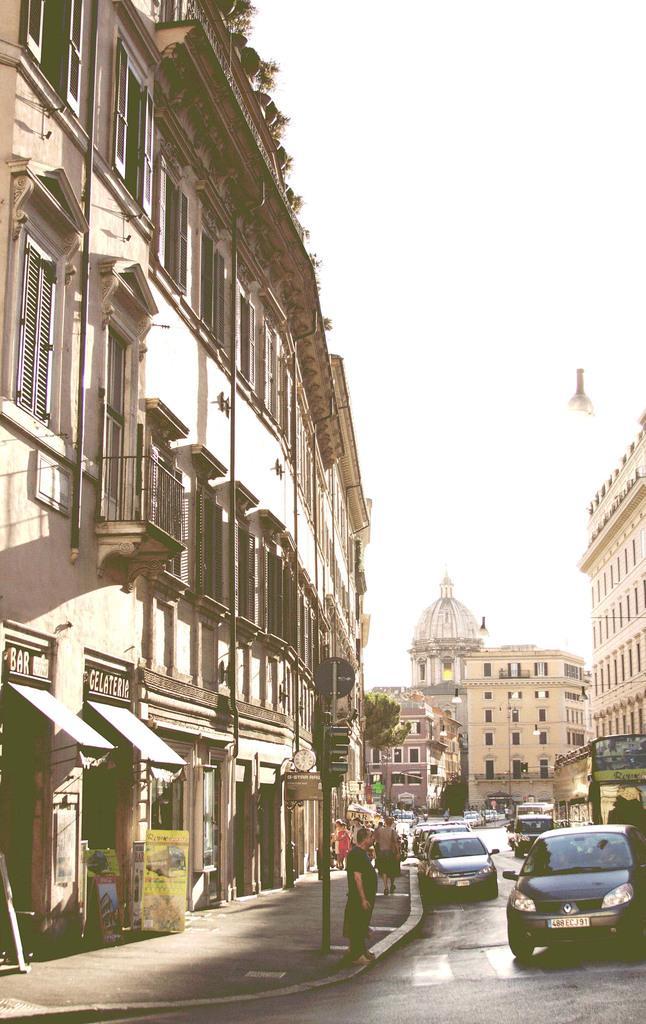Can you describe this image briefly? In this image there are buildings. At the bottom we can see cars on the road and there are people. There is a traffic pole. In the background there is sky and we can see a tree. 